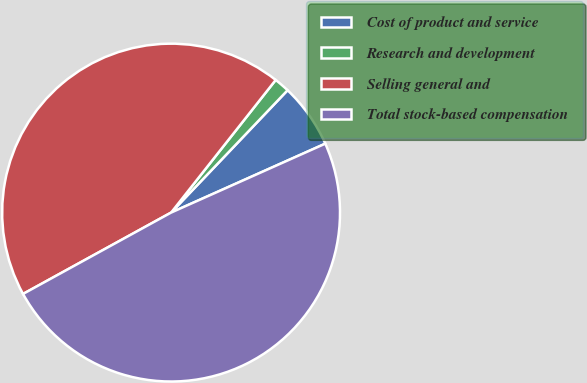Convert chart to OTSL. <chart><loc_0><loc_0><loc_500><loc_500><pie_chart><fcel>Cost of product and service<fcel>Research and development<fcel>Selling general and<fcel>Total stock-based compensation<nl><fcel>6.2%<fcel>1.48%<fcel>43.62%<fcel>48.69%<nl></chart> 